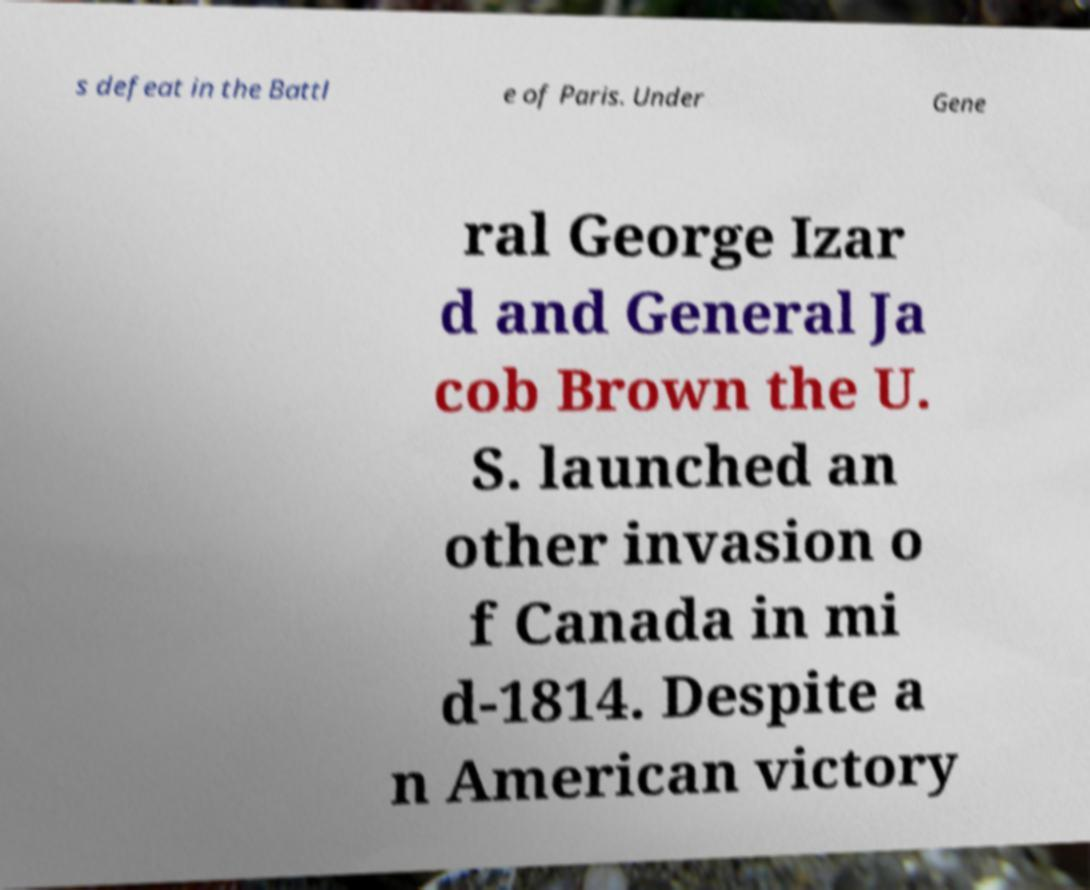For documentation purposes, I need the text within this image transcribed. Could you provide that? s defeat in the Battl e of Paris. Under Gene ral George Izar d and General Ja cob Brown the U. S. launched an other invasion o f Canada in mi d-1814. Despite a n American victory 